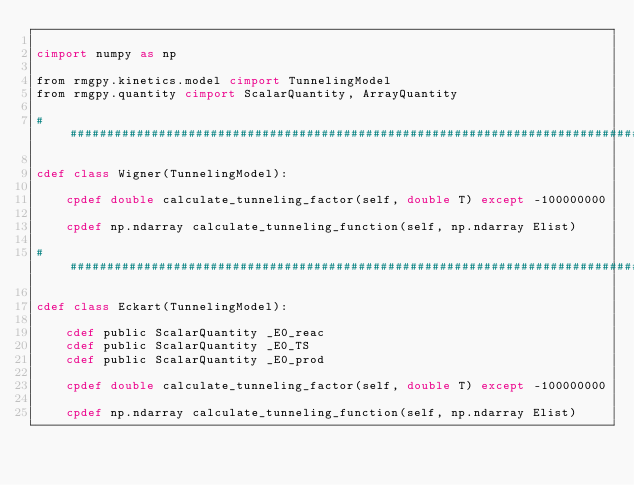Convert code to text. <code><loc_0><loc_0><loc_500><loc_500><_Cython_>
cimport numpy as np

from rmgpy.kinetics.model cimport TunnelingModel
from rmgpy.quantity cimport ScalarQuantity, ArrayQuantity

################################################################################

cdef class Wigner(TunnelingModel):

    cpdef double calculate_tunneling_factor(self, double T) except -100000000

    cpdef np.ndarray calculate_tunneling_function(self, np.ndarray Elist)

################################################################################

cdef class Eckart(TunnelingModel):

    cdef public ScalarQuantity _E0_reac
    cdef public ScalarQuantity _E0_TS
    cdef public ScalarQuantity _E0_prod

    cpdef double calculate_tunneling_factor(self, double T) except -100000000

    cpdef np.ndarray calculate_tunneling_function(self, np.ndarray Elist)
</code> 